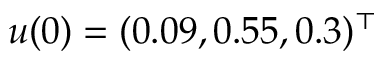Convert formula to latex. <formula><loc_0><loc_0><loc_500><loc_500>u ( 0 ) = ( 0 . 0 9 , 0 . 5 5 , 0 . 3 ) ^ { \top }</formula> 